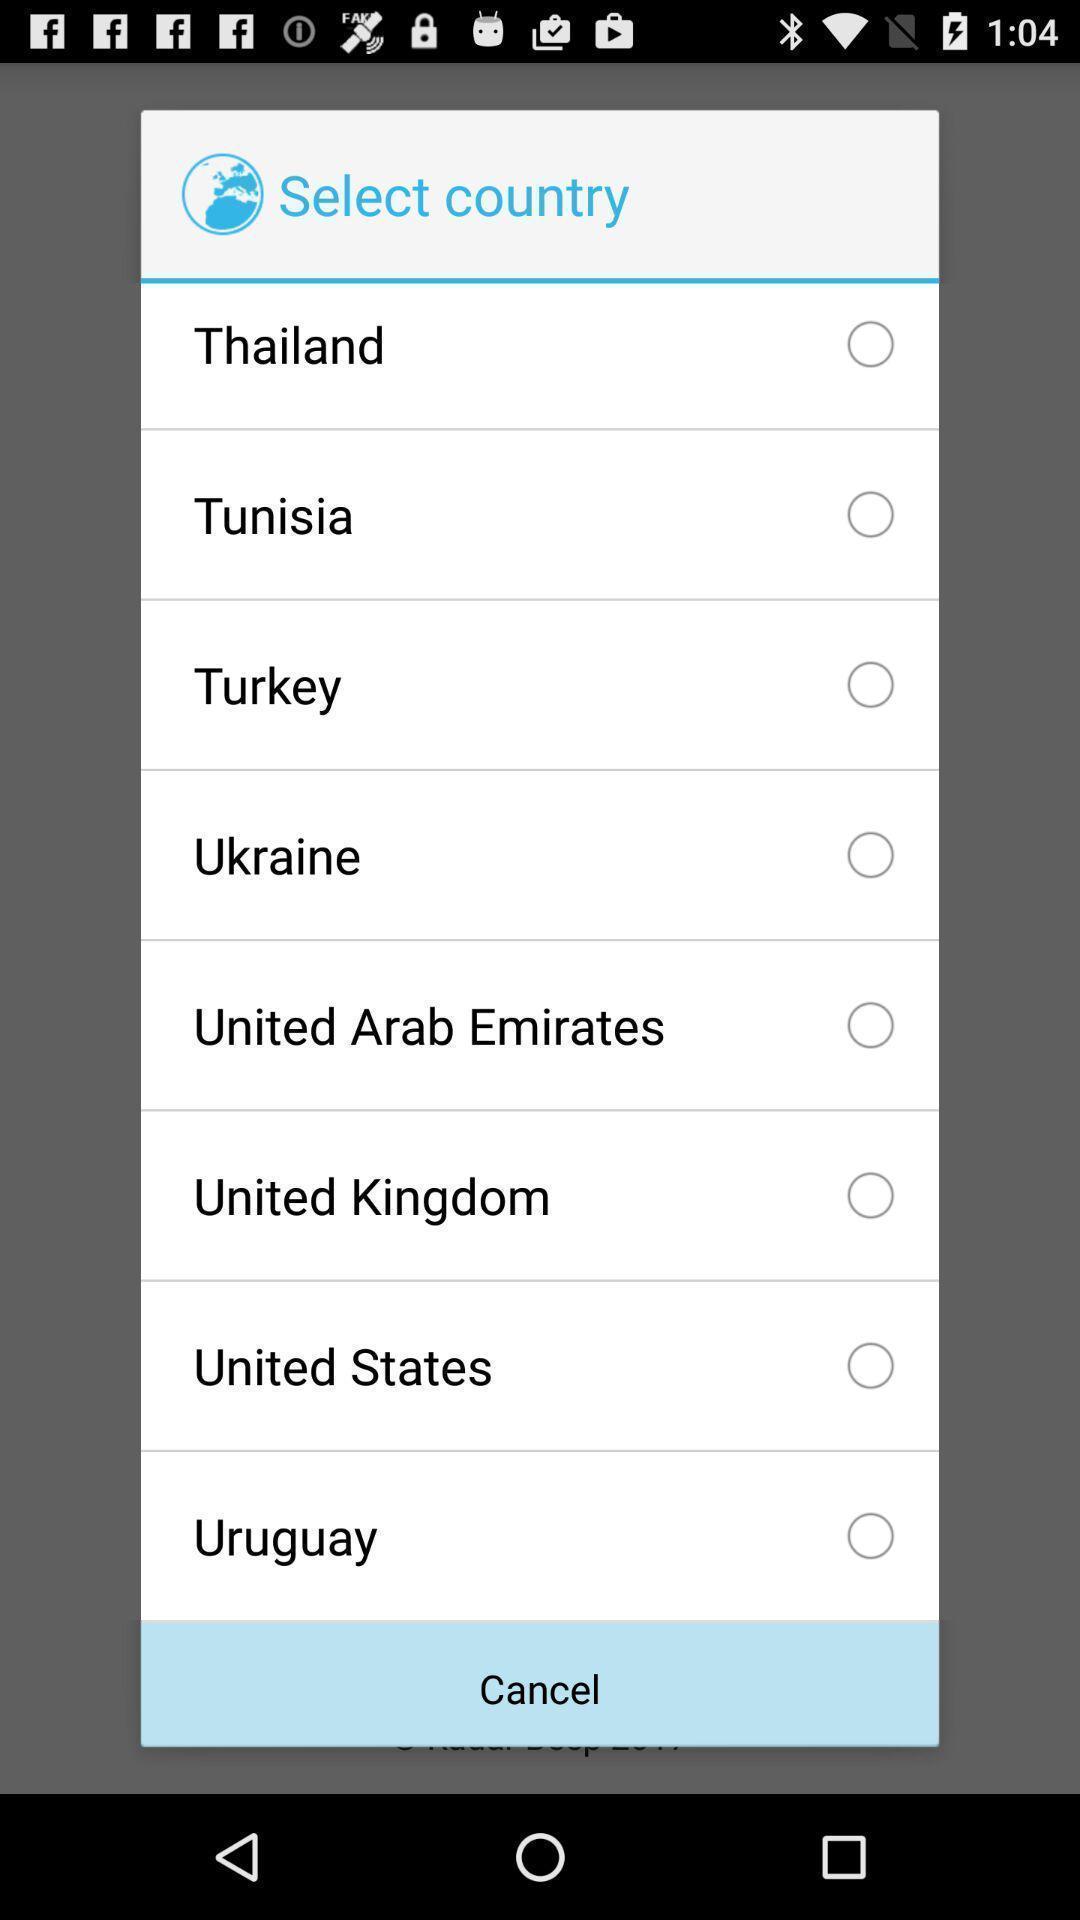Describe the key features of this screenshot. Pop-up displaying to select country in the app. 